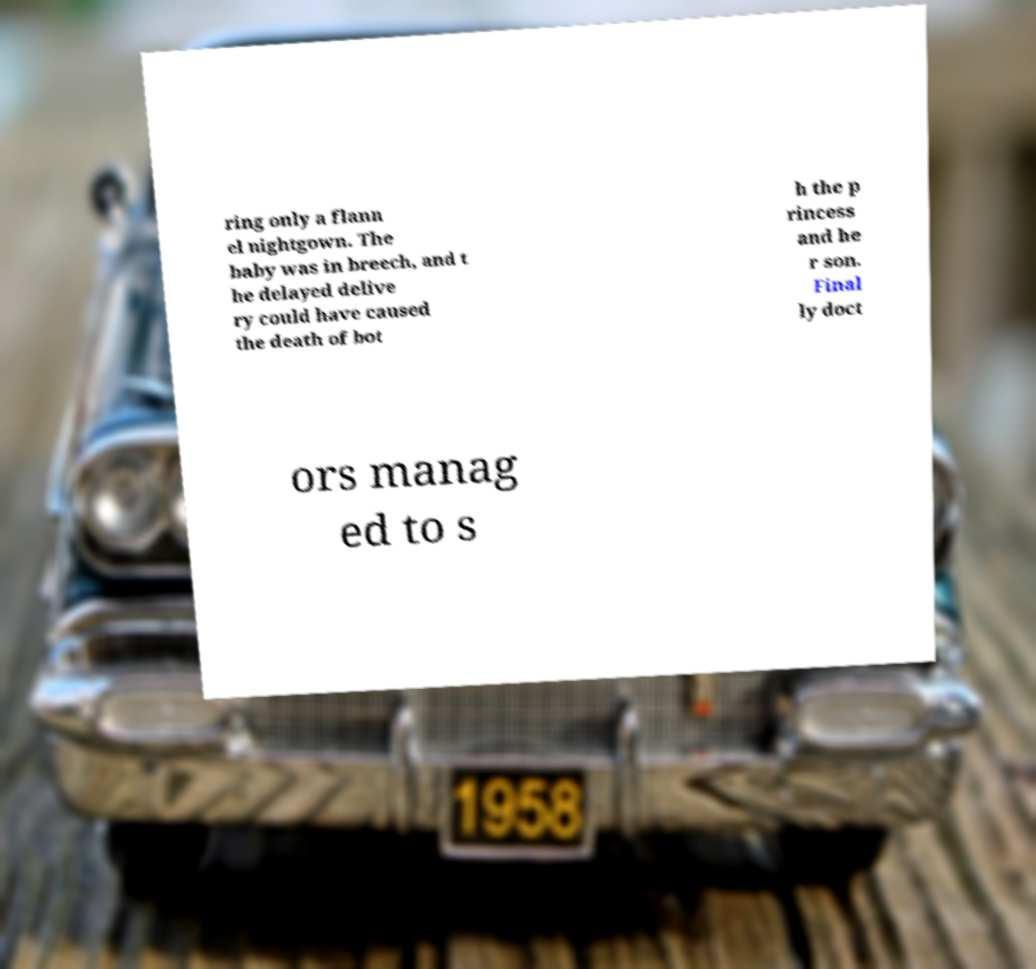Could you assist in decoding the text presented in this image and type it out clearly? ring only a flann el nightgown. The baby was in breech, and t he delayed delive ry could have caused the death of bot h the p rincess and he r son. Final ly doct ors manag ed to s 